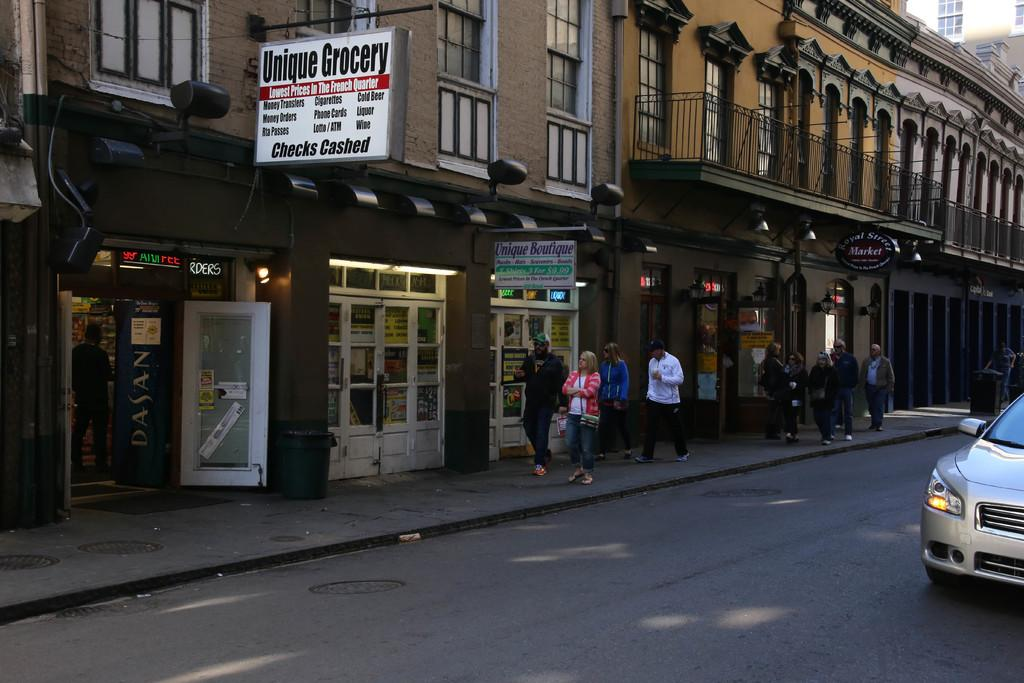What are the people in the image doing? There are persons walking in the center of the image. What can be seen on the right side of the image? There is a car on the right side of the image. What is visible in the background of the image? There are buildings and boards with text in the background of the image. Can you tell me how many grapes are on the car in the image? There are no grapes present on the car in the image. What type of tramp is visible in the background of the image? There is no tramp visible in the image; it features people walking, a car, buildings, and boards with text. 